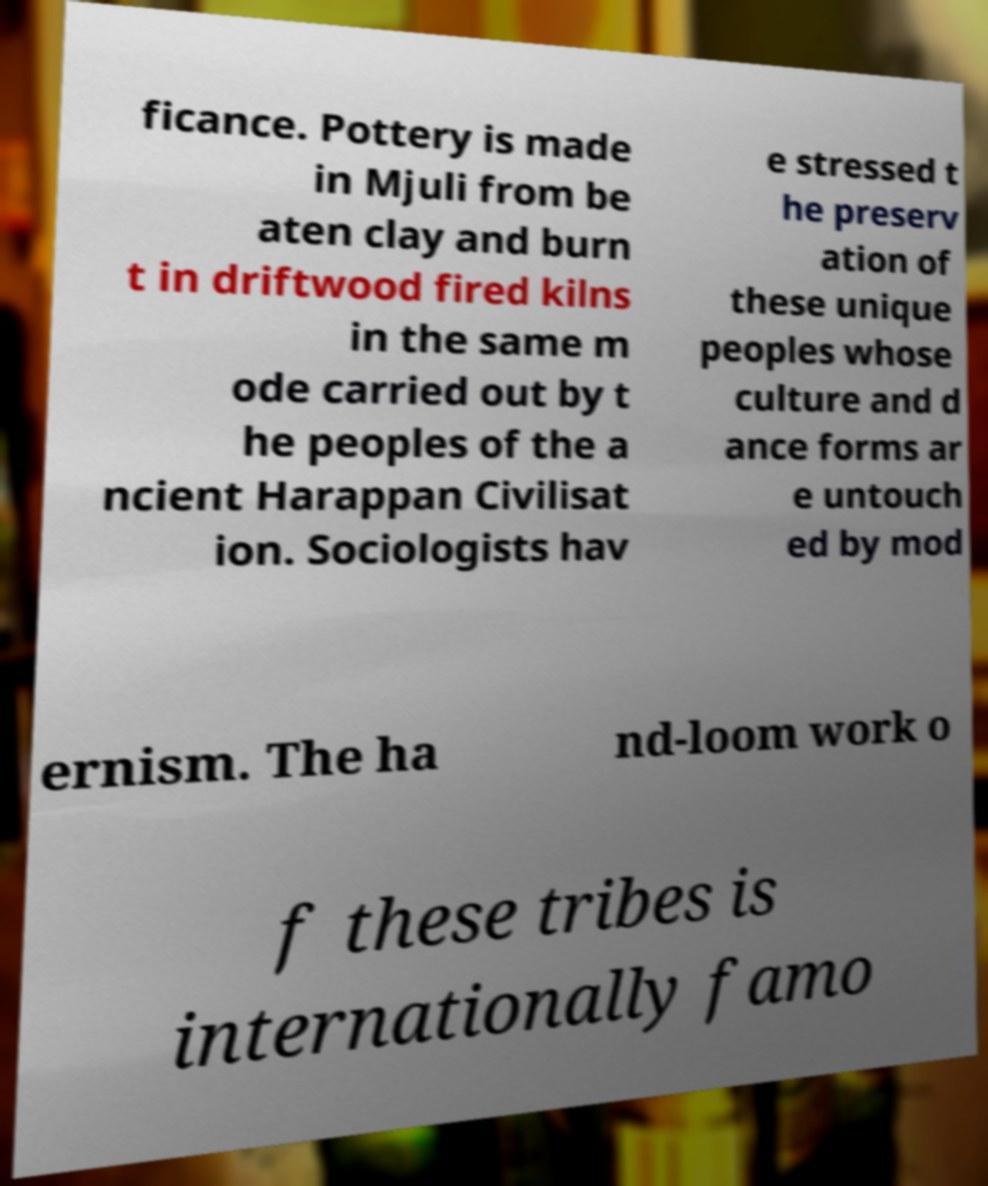Can you read and provide the text displayed in the image?This photo seems to have some interesting text. Can you extract and type it out for me? ficance. Pottery is made in Mjuli from be aten clay and burn t in driftwood fired kilns in the same m ode carried out by t he peoples of the a ncient Harappan Civilisat ion. Sociologists hav e stressed t he preserv ation of these unique peoples whose culture and d ance forms ar e untouch ed by mod ernism. The ha nd-loom work o f these tribes is internationally famo 